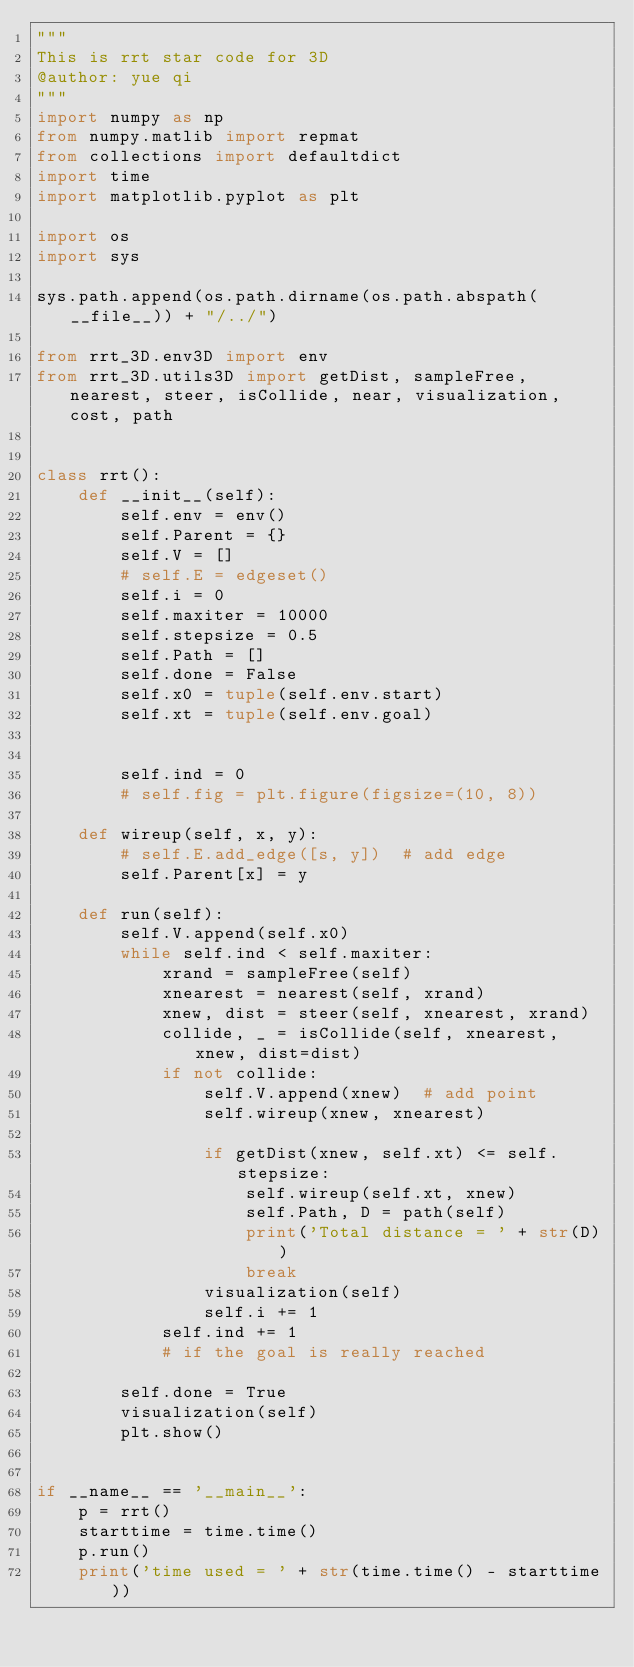Convert code to text. <code><loc_0><loc_0><loc_500><loc_500><_Python_>"""
This is rrt star code for 3D
@author: yue qi
"""
import numpy as np
from numpy.matlib import repmat
from collections import defaultdict
import time
import matplotlib.pyplot as plt

import os
import sys

sys.path.append(os.path.dirname(os.path.abspath(__file__)) + "/../")

from rrt_3D.env3D import env
from rrt_3D.utils3D import getDist, sampleFree, nearest, steer, isCollide, near, visualization, cost, path


class rrt():
    def __init__(self):
        self.env = env()
        self.Parent = {}
        self.V = []
        # self.E = edgeset()
        self.i = 0
        self.maxiter = 10000
        self.stepsize = 0.5
        self.Path = []
        self.done = False
        self.x0 = tuple(self.env.start)
        self.xt = tuple(self.env.goal)

        
        self.ind = 0
        # self.fig = plt.figure(figsize=(10, 8))

    def wireup(self, x, y):
        # self.E.add_edge([s, y])  # add edge
        self.Parent[x] = y

    def run(self):
        self.V.append(self.x0)
        while self.ind < self.maxiter:
            xrand = sampleFree(self)
            xnearest = nearest(self, xrand)
            xnew, dist = steer(self, xnearest, xrand)
            collide, _ = isCollide(self, xnearest, xnew, dist=dist)
            if not collide:
                self.V.append(xnew)  # add point
                self.wireup(xnew, xnearest)

                if getDist(xnew, self.xt) <= self.stepsize:
                    self.wireup(self.xt, xnew)
                    self.Path, D = path(self)
                    print('Total distance = ' + str(D))
                    break
                visualization(self)
                self.i += 1
            self.ind += 1
            # if the goal is really reached
            
        self.done = True
        visualization(self)
        plt.show()


if __name__ == '__main__':
    p = rrt()
    starttime = time.time()
    p.run()
    print('time used = ' + str(time.time() - starttime))
</code> 